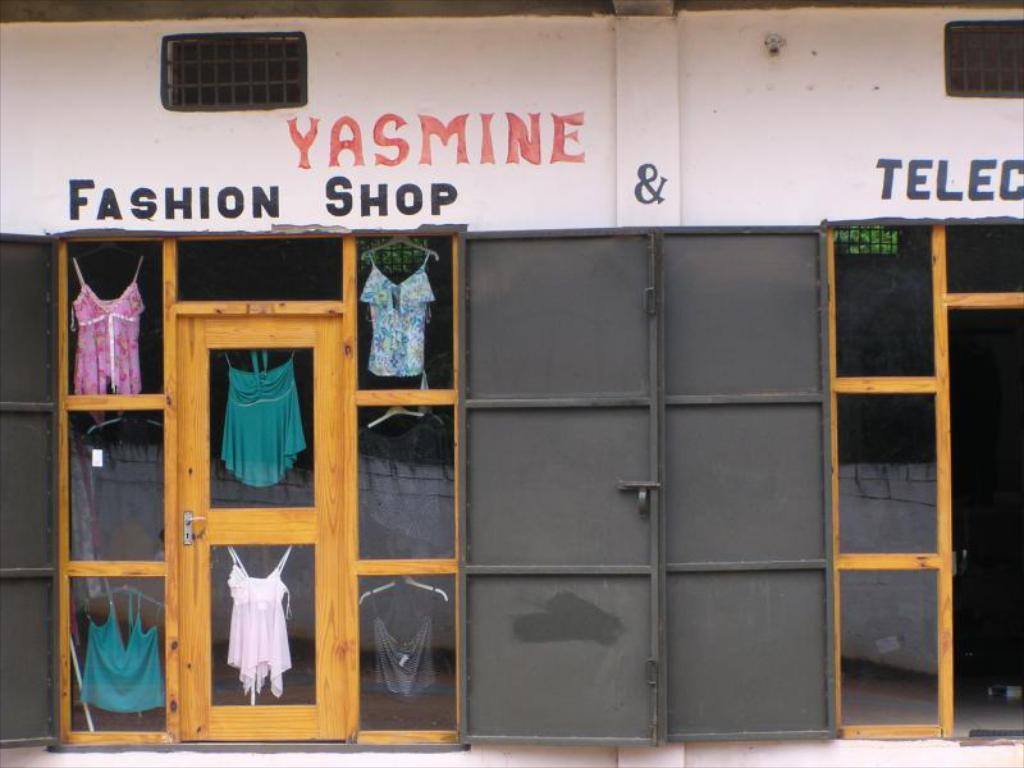Provide a one-sentence caption for the provided image. The doorway of Yasmine Fashion Shop shows a few shirts in glass. 